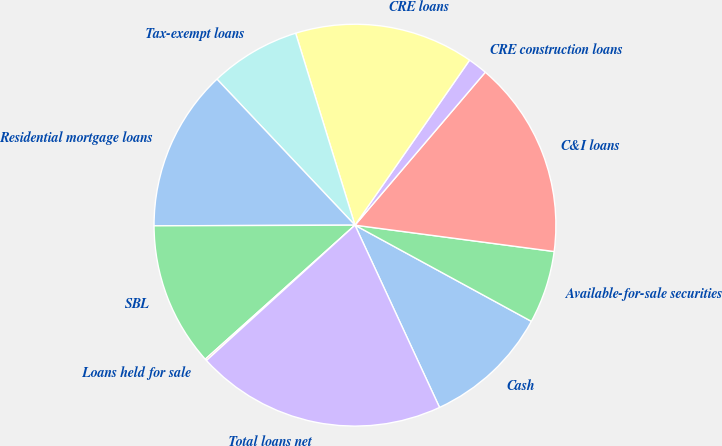Convert chart to OTSL. <chart><loc_0><loc_0><loc_500><loc_500><pie_chart><fcel>Cash<fcel>Available-for-sale securities<fcel>C&I loans<fcel>CRE construction loans<fcel>CRE loans<fcel>Tax-exempt loans<fcel>Residential mortgage loans<fcel>SBL<fcel>Loans held for sale<fcel>Total loans net<nl><fcel>10.14%<fcel>5.85%<fcel>15.86%<fcel>1.57%<fcel>14.43%<fcel>7.28%<fcel>13.0%<fcel>11.57%<fcel>0.14%<fcel>20.15%<nl></chart> 